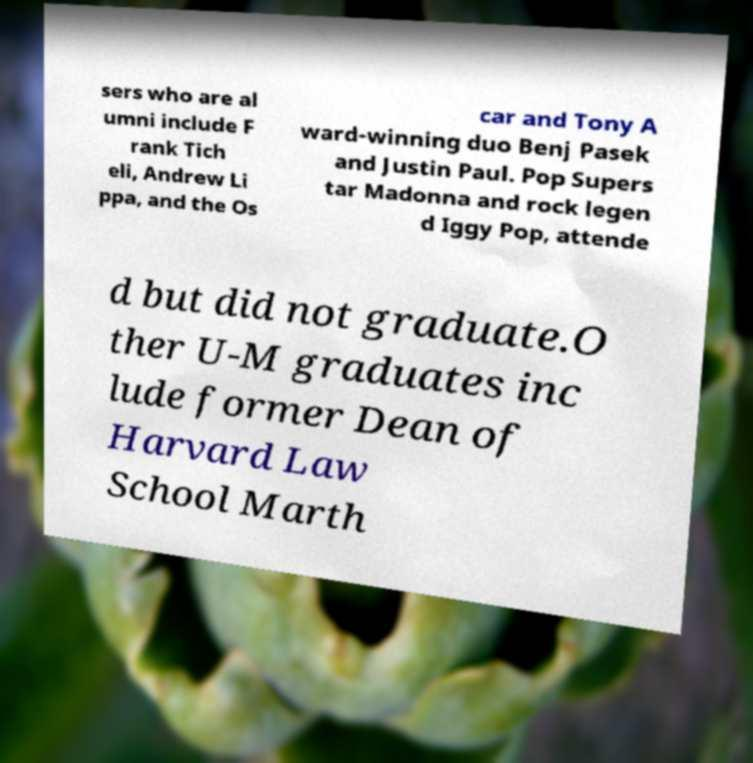I need the written content from this picture converted into text. Can you do that? sers who are al umni include F rank Tich eli, Andrew Li ppa, and the Os car and Tony A ward-winning duo Benj Pasek and Justin Paul. Pop Supers tar Madonna and rock legen d Iggy Pop, attende d but did not graduate.O ther U-M graduates inc lude former Dean of Harvard Law School Marth 